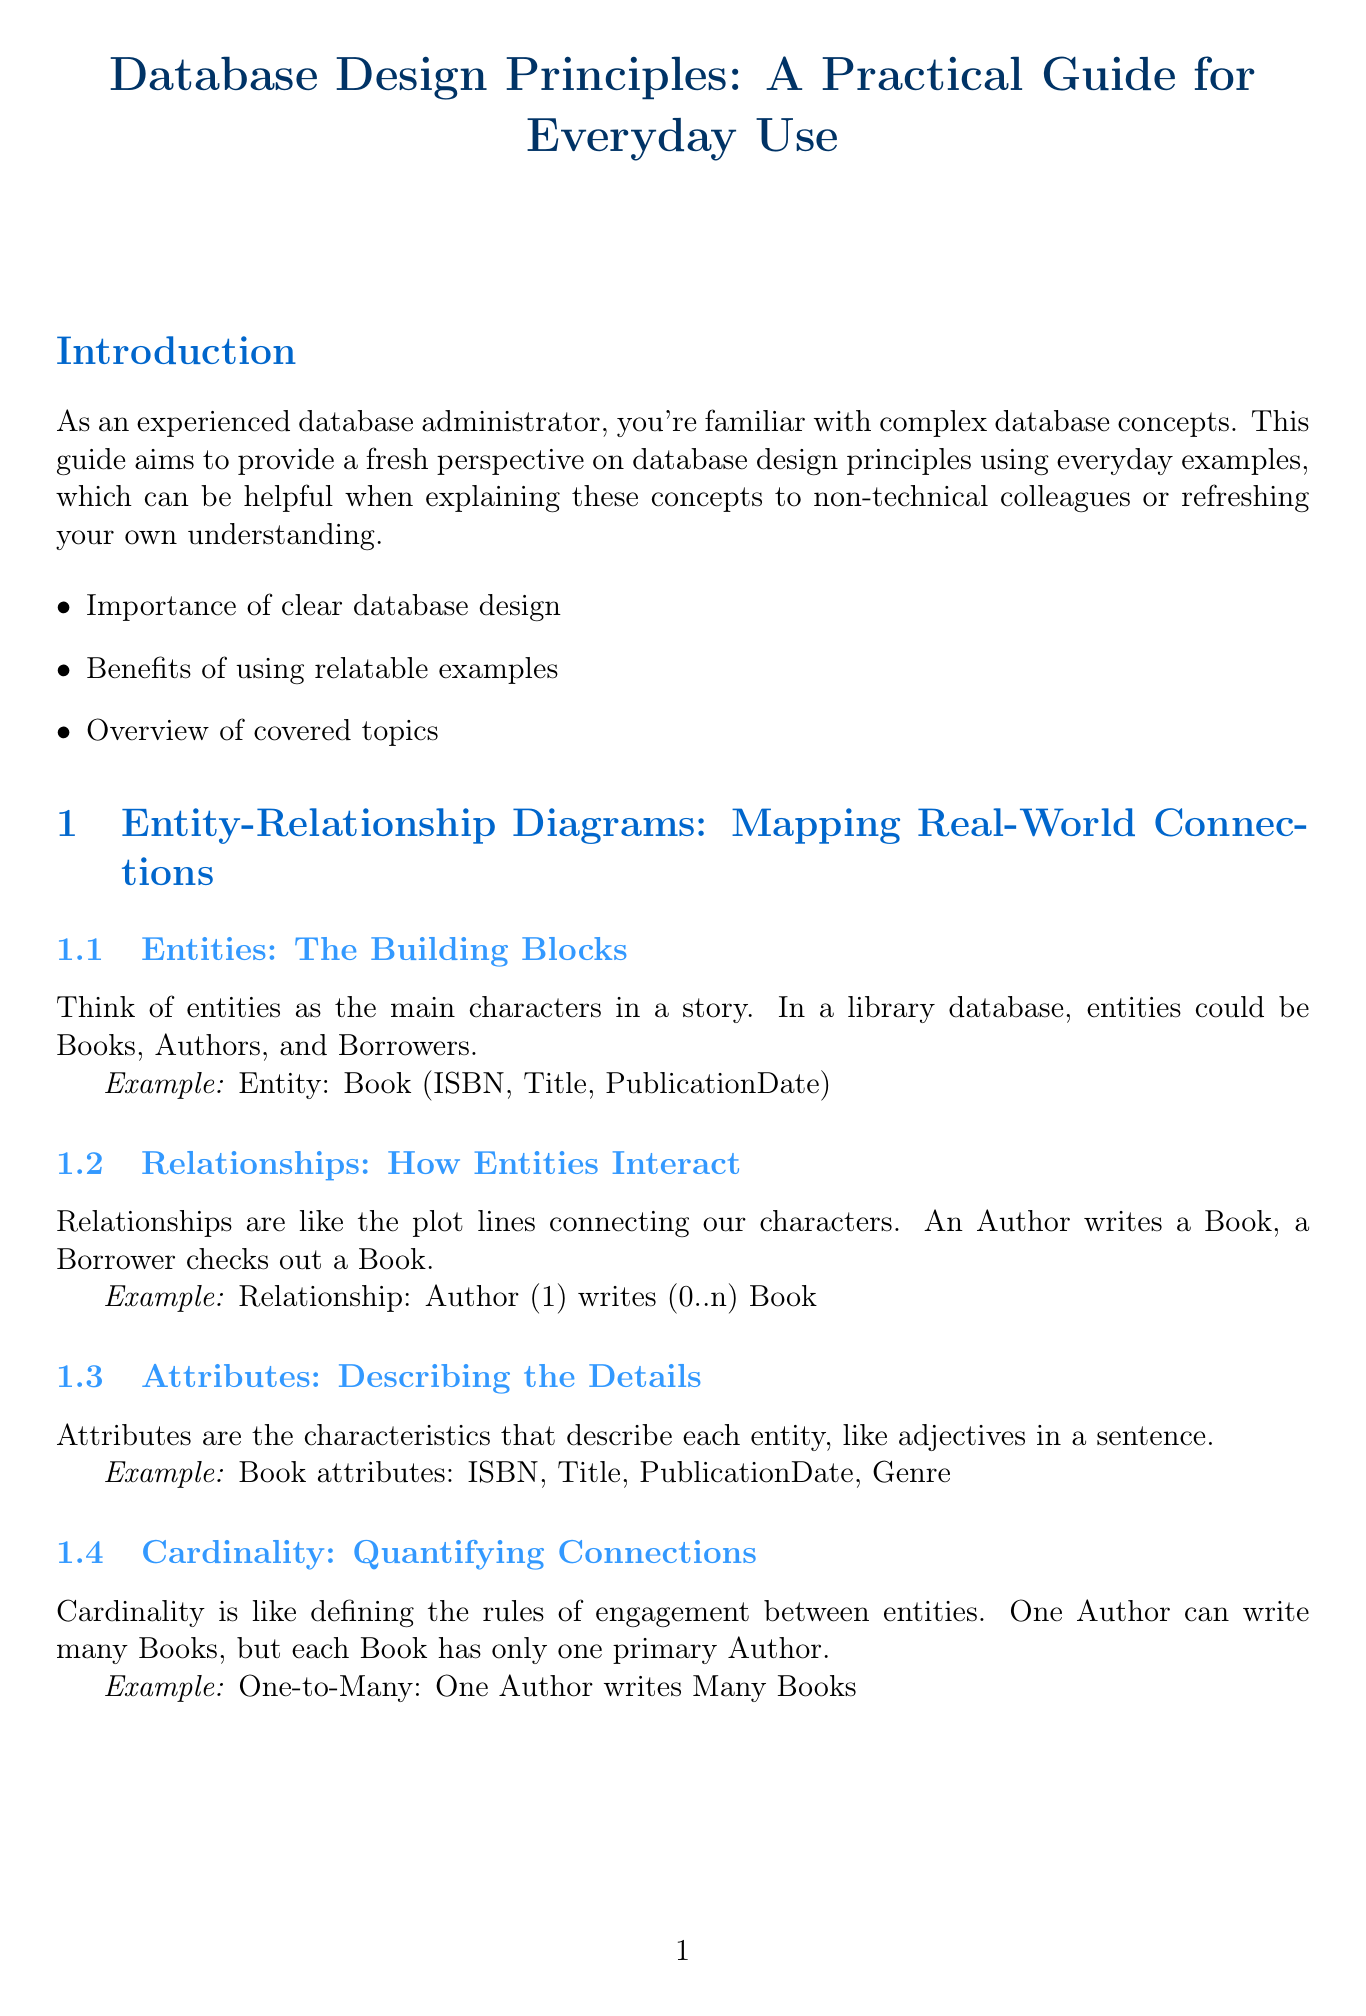What is the title of the manual? The title is provided in the header of the document as the main heading.
Answer: Database Design Principles: A Practical Guide for Everyday Use How many chapters are there in the manual? The number of chapters can be counted from the contents listed in the document.
Answer: Three What example is used to explain entities? Specific examples are given to illustrate the concept of entities in the document.
Answer: Entity: Book (ISBN, Title, PublicationDate) What does 1NF stand for in normalization? The abbreviation is typically defined in the context of data normalization principles discussed in the document.
Answer: First Normal Form What analogy is used for Third Normal Form? The analogy used helps to clarify the concept by relating it to a familiar situation.
Answer: Fuel efficiency and color What is the title of the practical application chapter? The title indicates the focus on real-world application within the context of the document.
Answer: Practical Application: Designing a Restaurant Management System Which entity serves a customer in the restaurant example? The specific role of an entity is highlighted in the relationships section for clarity.
Answer: Staff How many key takeaways are listed in the conclusion? The number can be counted from the conclusion section where they are presented.
Answer: Three What is the main benefit of using relatable examples according to the introduction? This benefit is mentioned in the introductory section discussing the purpose of the manual.
Answer: Understanding What is the relationship between an author and a book? The document describes the specific type of relationship between these entities.
Answer: One Author writes Many Books 